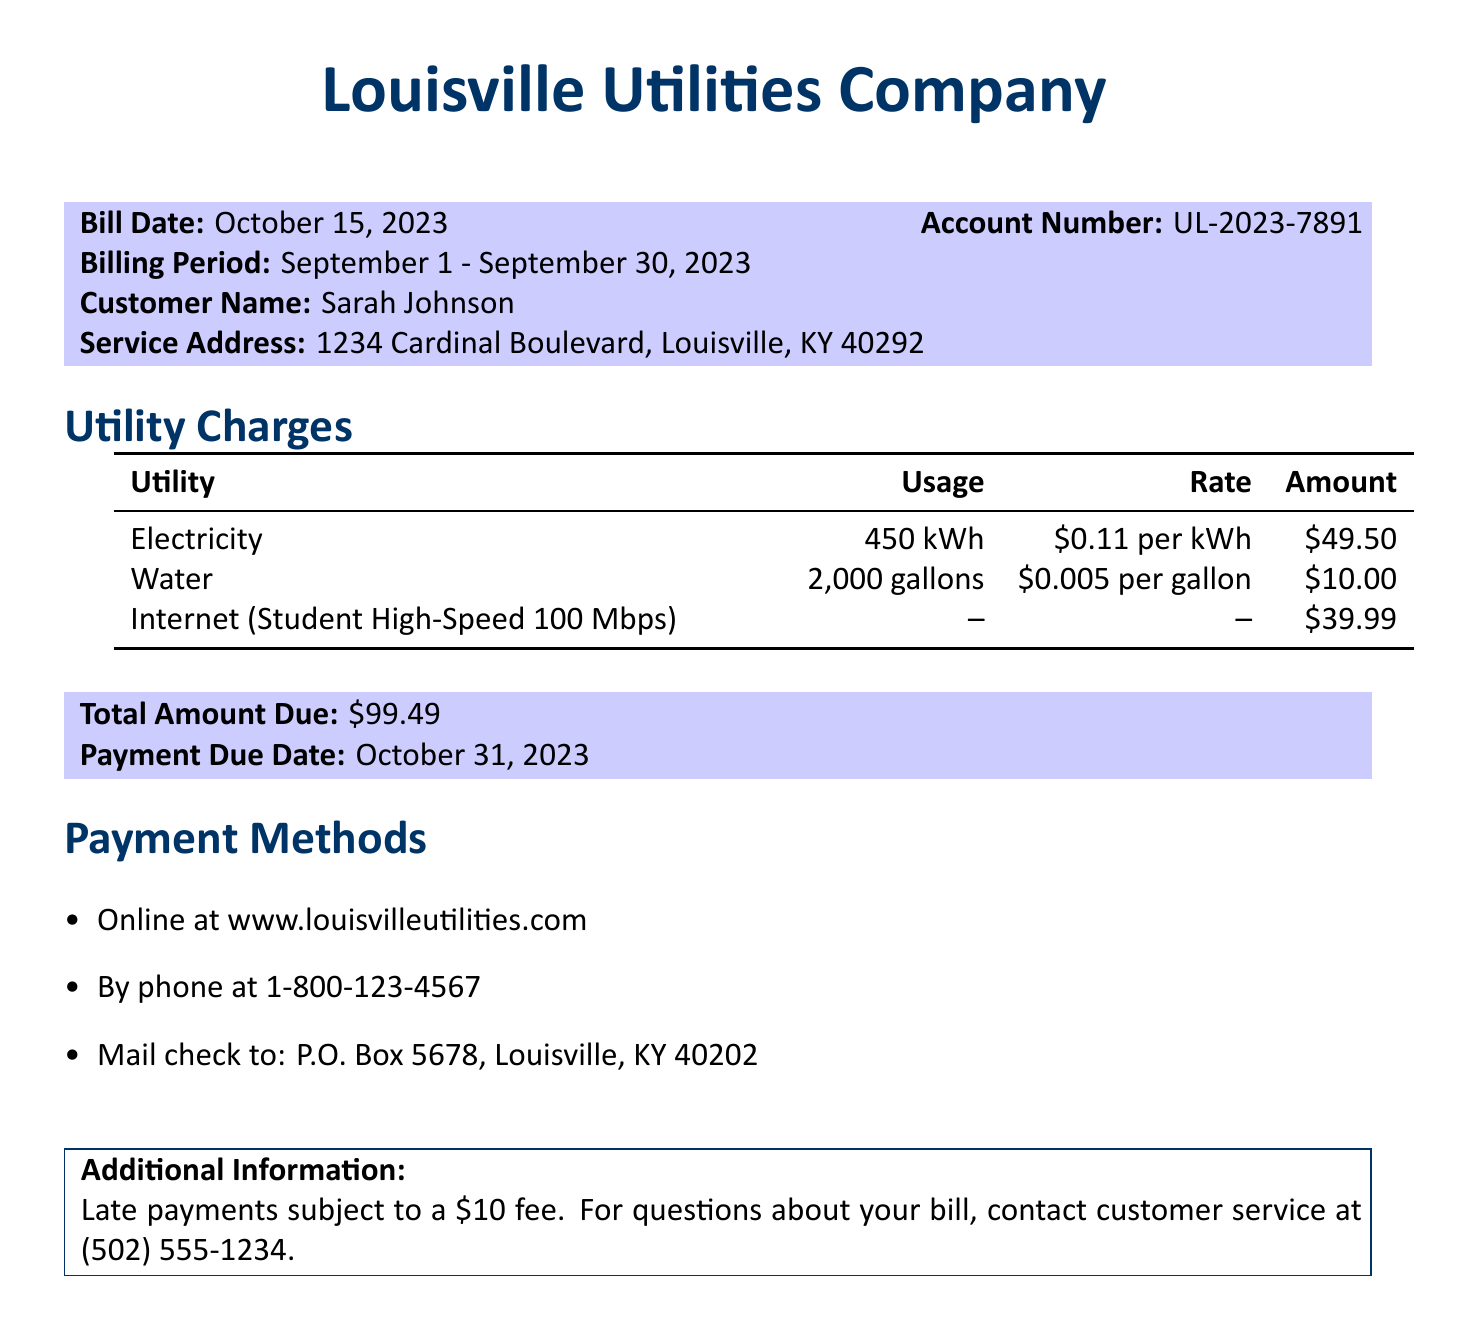What is the bill date? The bill date is stated in the document, specifying when the bill was issued.
Answer: October 15, 2023 What is the total amount due? The total amount due is calculated at the end of the document, representing the overall charges on the bill.
Answer: $99.49 How many gallons of water were used? The document lists the water usage as part of the utility charges section.
Answer: 2,000 gallons What is the customer service phone number? The document provides a contact number for customer service related to the bill inquiries.
Answer: (502) 555-1234 What is the payment due date? The payment due date is mentioned in the section detailing the total amount due.
Answer: October 31, 2023 What is the rate for electricity? The document specifies the rate charged per unit of electricity used.
Answer: $0.11 per kWh What are the payment methods listed? The document outlines different ways the customer can make their payment.
Answer: Online, By phone, Mail check What is the usage of electricity? The electricity usage is quantified in the utility charges section of the document.
Answer: 450 kWh What is the internet service type mentioned? The document describes the internet service provided as a specific high-speed package.
Answer: Student High-Speed 100 Mbps 